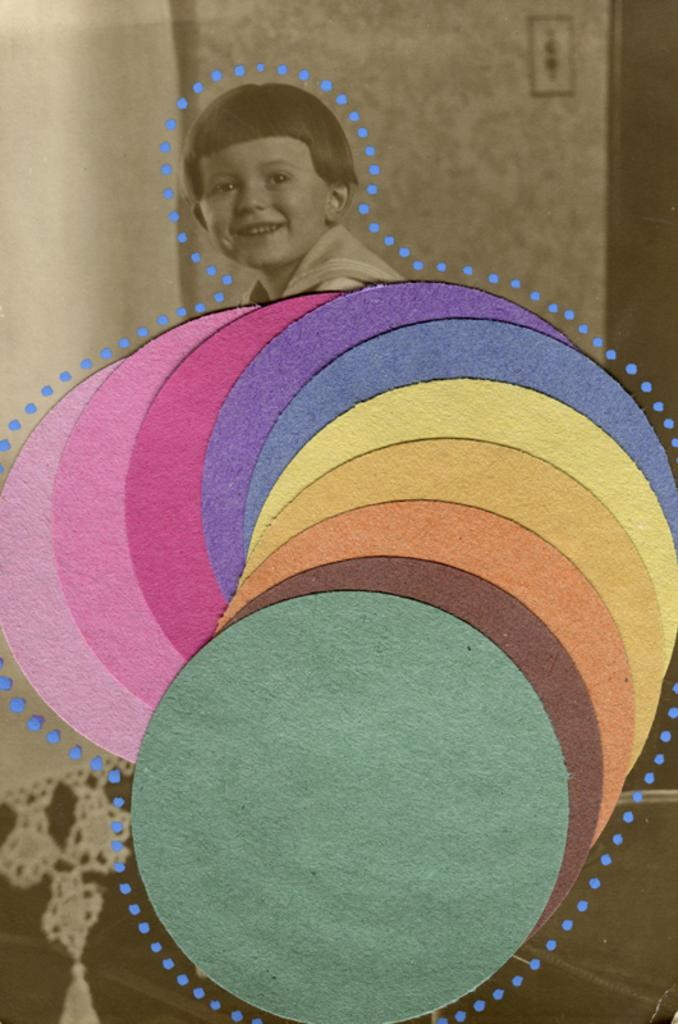What is the main subject of the image? The main subject of the image is a kid. What is the kid's expression in the image? The kid is smiling in the image. Can you describe the color scheme of the image? There are different colors in the image. What can be seen in the background of the image? There is a curtain and an object attached to the wall in the background of the image. What type of verse can be heard in the image? There is no audible verse in the image, as it is a still photograph. How many spiders are visible on the kid's shoulder in the image? There are no spiders visible on the kid's shoulder in the image. 